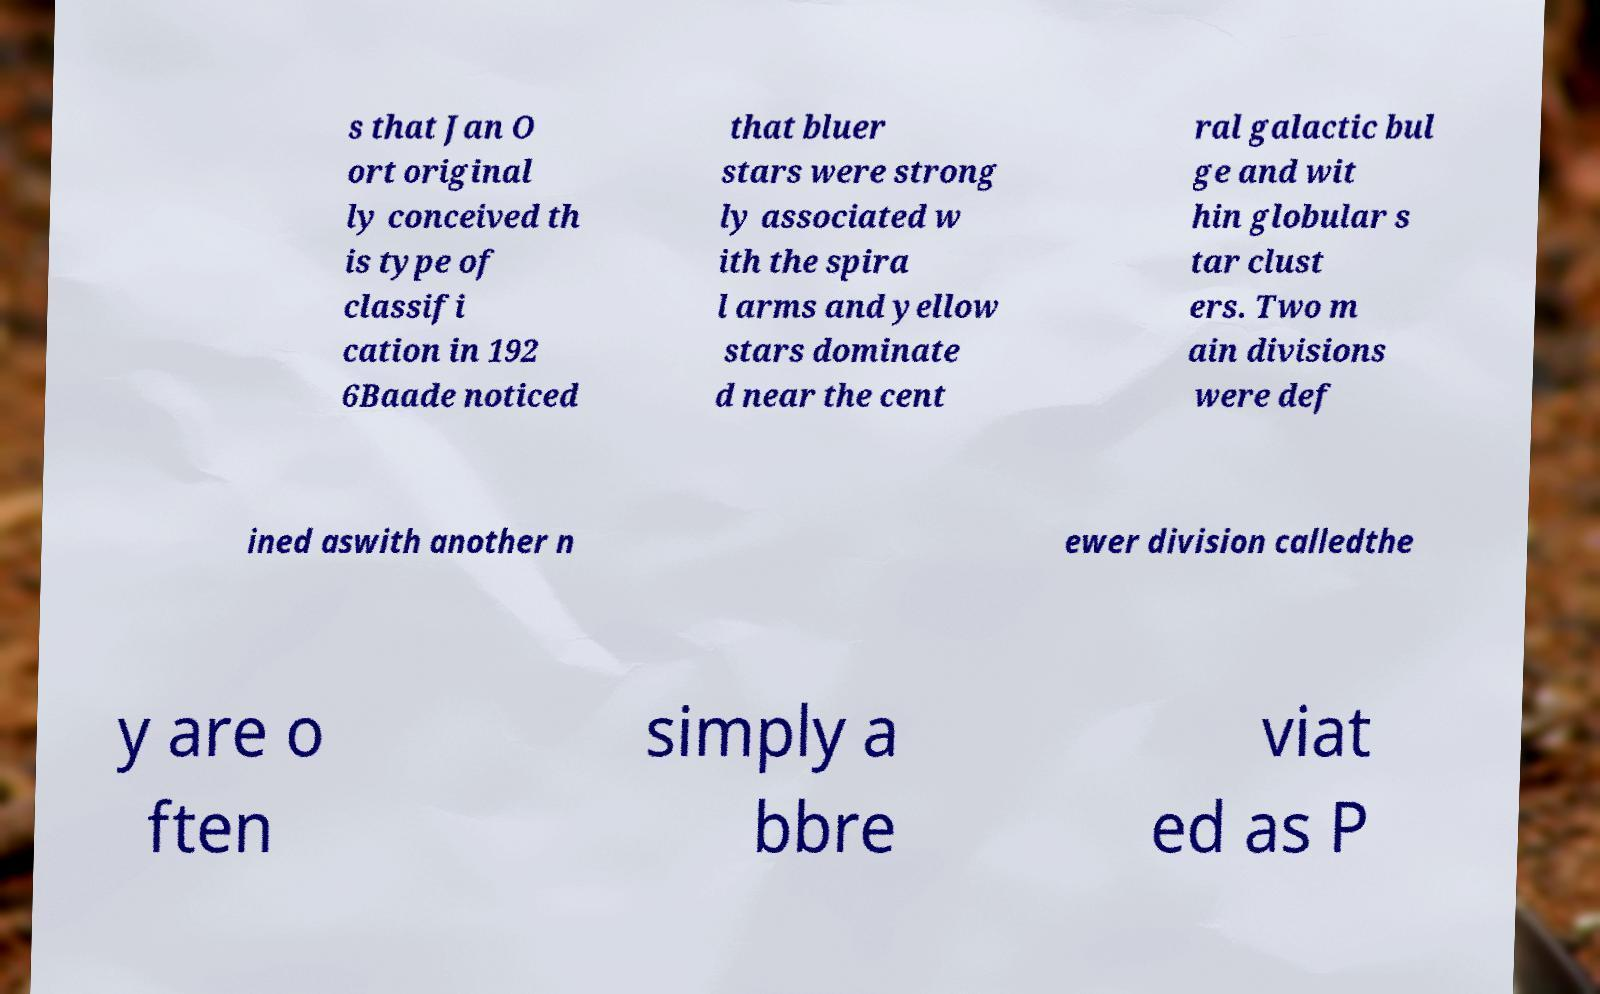Could you assist in decoding the text presented in this image and type it out clearly? s that Jan O ort original ly conceived th is type of classifi cation in 192 6Baade noticed that bluer stars were strong ly associated w ith the spira l arms and yellow stars dominate d near the cent ral galactic bul ge and wit hin globular s tar clust ers. Two m ain divisions were def ined aswith another n ewer division calledthe y are o ften simply a bbre viat ed as P 